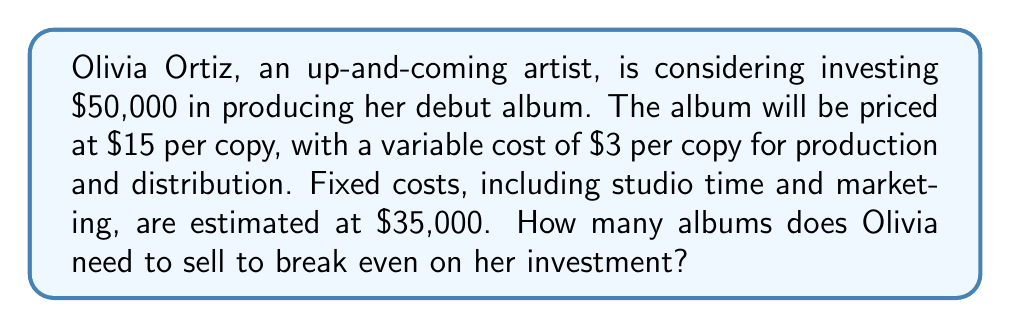Help me with this question. To solve this problem, we need to use the break-even analysis formula. The break-even point is where total revenue equals total costs.

Let's define our variables:
$x$ = number of albums sold
$p$ = price per album = $15
$v$ = variable cost per album = $3
$F$ = fixed costs = $35,000
$I$ = initial investment = $50,000

Total revenue: $R = px$
Total variable costs: $VC = vx$
Total fixed costs: $FC = F + I = 35,000 + 50,000 = 85,000$

At the break-even point:
$R = VC + FC$

Substituting our variables:
$15x = 3x + 85,000$

Solving for $x$:
$15x - 3x = 85,000$
$12x = 85,000$

$x = \frac{85,000}{12} = 7,083.33$

Since we can't sell a fraction of an album, we round up to the nearest whole number.
Answer: Olivia needs to sell 7,084 albums to break even on her investment. 